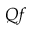<formula> <loc_0><loc_0><loc_500><loc_500>Q f</formula> 